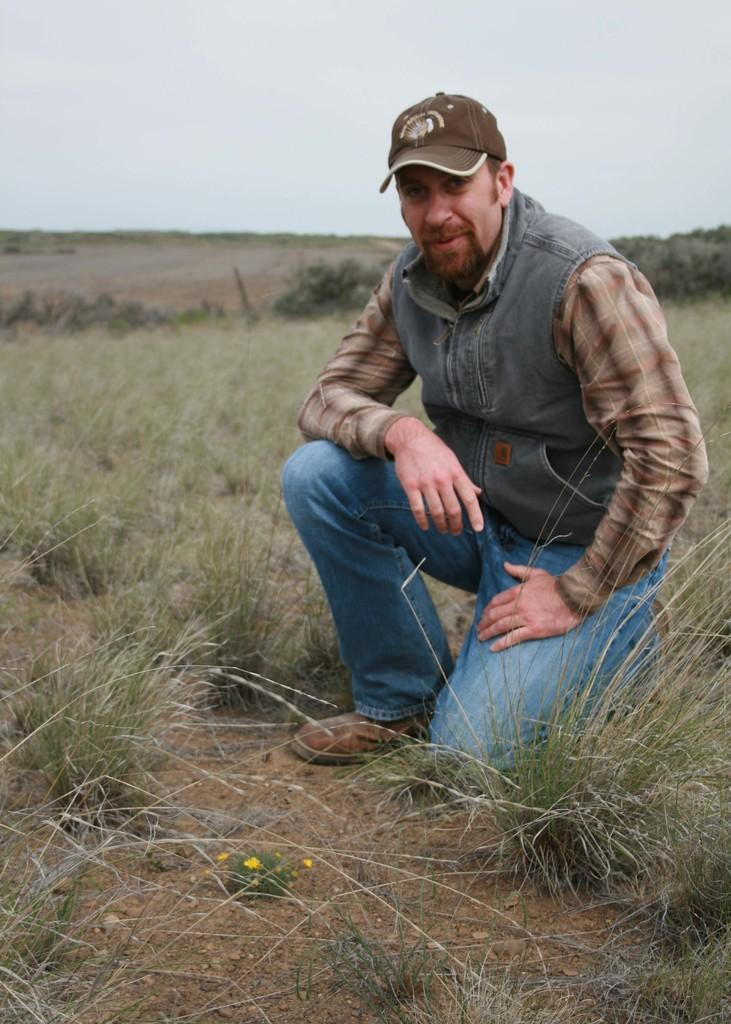What is the main setting of the image? There is an open grass ground in the image. Can you describe the person in the image? There is a man in the front of the image, and he is wearing a shirt, a jacket, a cap, blue color jeans, and brown shoes. What type of drum can be seen in the man's hand in the image? There is no drum present in the image; the man is not holding any musical instruments. What type of furniture is visible in the background of the image? There is no furniture visible in the image; the background only shows the open grass ground. 